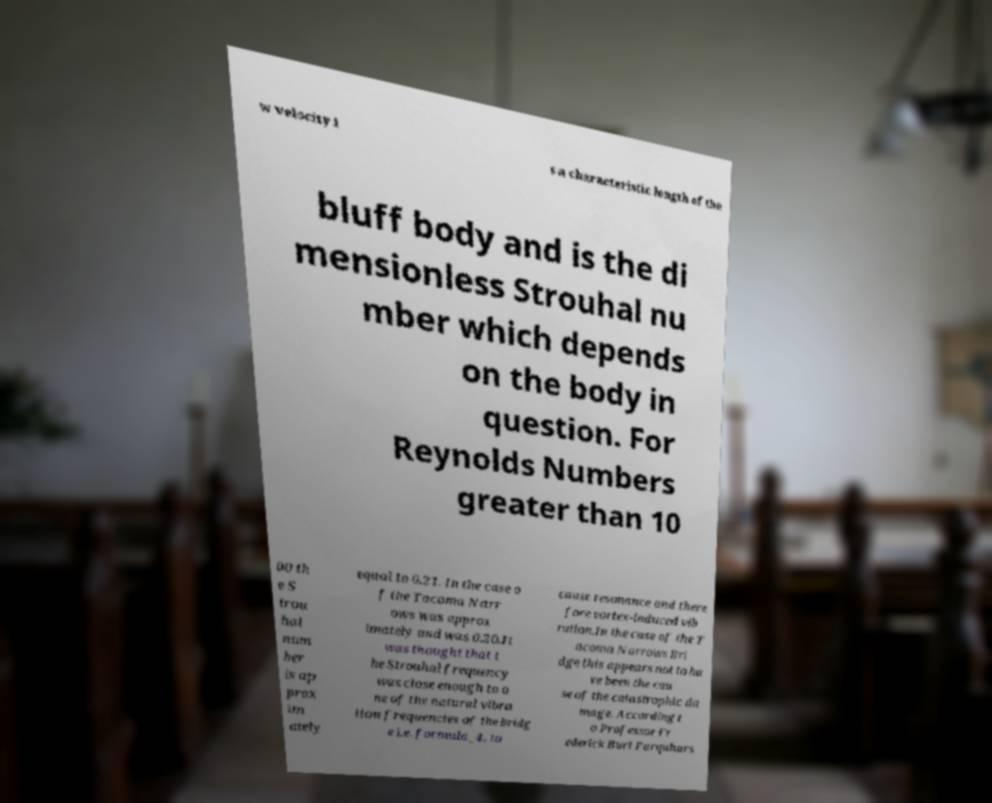Could you extract and type out the text from this image? w velocity i s a characteristic length of the bluff body and is the di mensionless Strouhal nu mber which depends on the body in question. For Reynolds Numbers greater than 10 00 th e S trou hal num ber is ap prox im ately equal to 0.21. In the case o f the Tacoma Narr ows was approx imately and was 0.20.It was thought that t he Strouhal frequency was close enough to o ne of the natural vibra tion frequencies of the bridg e i.e. formula_4, to cause resonance and there fore vortex-induced vib ration.In the case of the T acoma Narrows Bri dge this appears not to ha ve been the cau se of the catastrophic da mage. According t o Professor Fr ederick Burt Farquhars 